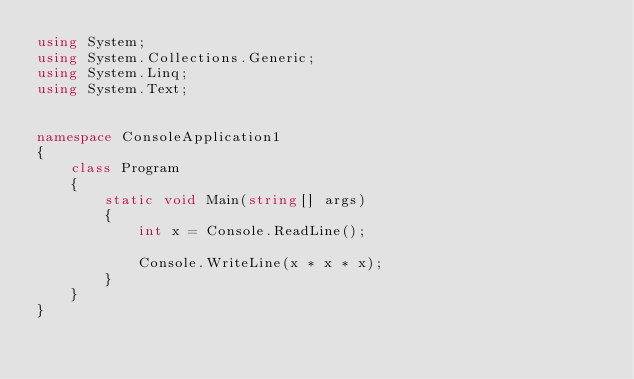Convert code to text. <code><loc_0><loc_0><loc_500><loc_500><_C#_>using System;
using System.Collections.Generic;
using System.Linq;
using System.Text;


namespace ConsoleApplication1
{
    class Program
    {
        static void Main(string[] args)
        {
            int x = Console.ReadLine();

            Console.WriteLine(x * x * x);
        }
    }
}</code> 